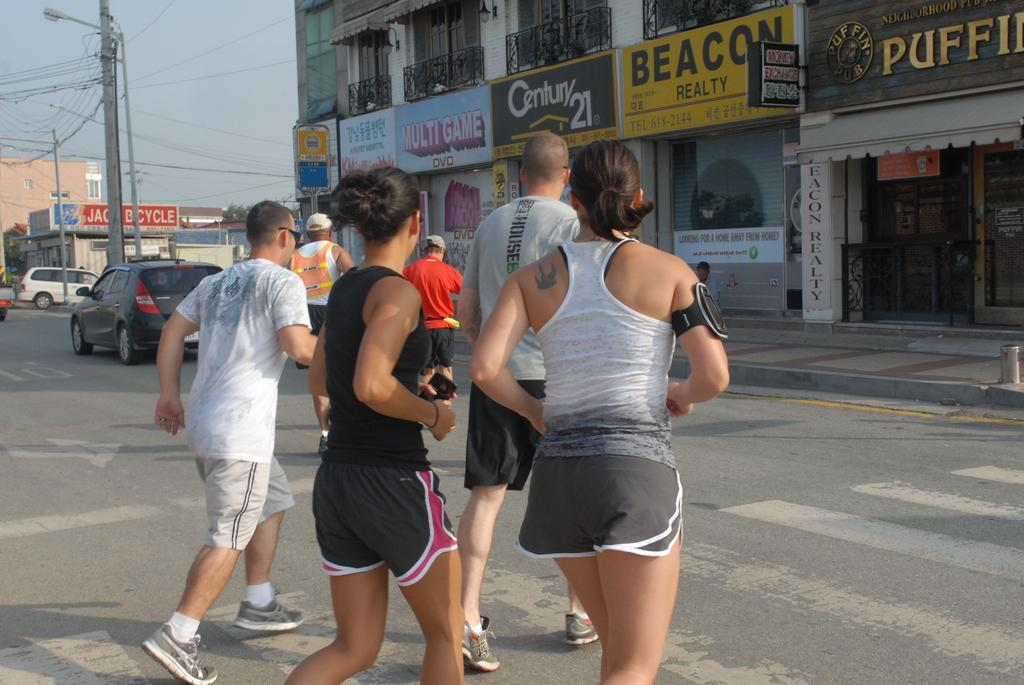<image>
Provide a brief description of the given image. People are jogging near a Century 21 real estate office. 